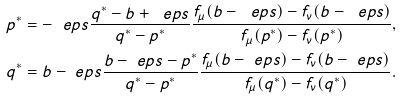<formula> <loc_0><loc_0><loc_500><loc_500>p ^ { * } = - \ e p s \frac { q ^ { * } - b + \ e p s } { q ^ { * } - p ^ { * } } \frac { f _ { \mu } ( b - \ e p s ) - f _ { \nu } ( b - \ e p s ) } { f _ { \mu } ( p ^ { * } ) - f _ { \nu } ( p ^ { * } ) } , \\ q ^ { * } = b - \ e p s \frac { b - \ e p s - p ^ { * } } { q ^ { * } - p ^ { * } } \frac { f _ { \mu } ( b - \ e p s ) - f _ { \nu } ( b - \ e p s ) } { f _ { \mu } ( q ^ { * } ) - f _ { \nu } ( q ^ { * } ) } .</formula> 